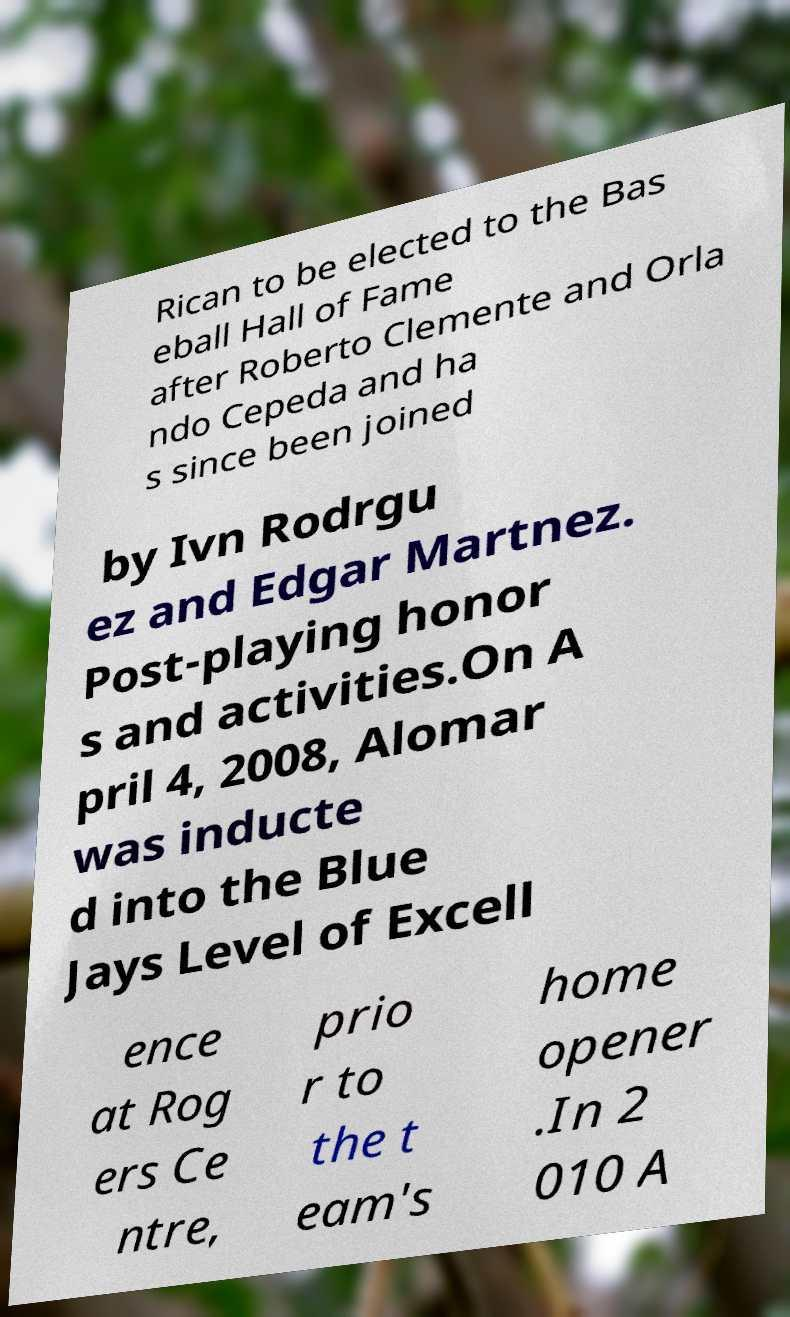Can you accurately transcribe the text from the provided image for me? Rican to be elected to the Bas eball Hall of Fame after Roberto Clemente and Orla ndo Cepeda and ha s since been joined by Ivn Rodrgu ez and Edgar Martnez. Post-playing honor s and activities.On A pril 4, 2008, Alomar was inducte d into the Blue Jays Level of Excell ence at Rog ers Ce ntre, prio r to the t eam's home opener .In 2 010 A 